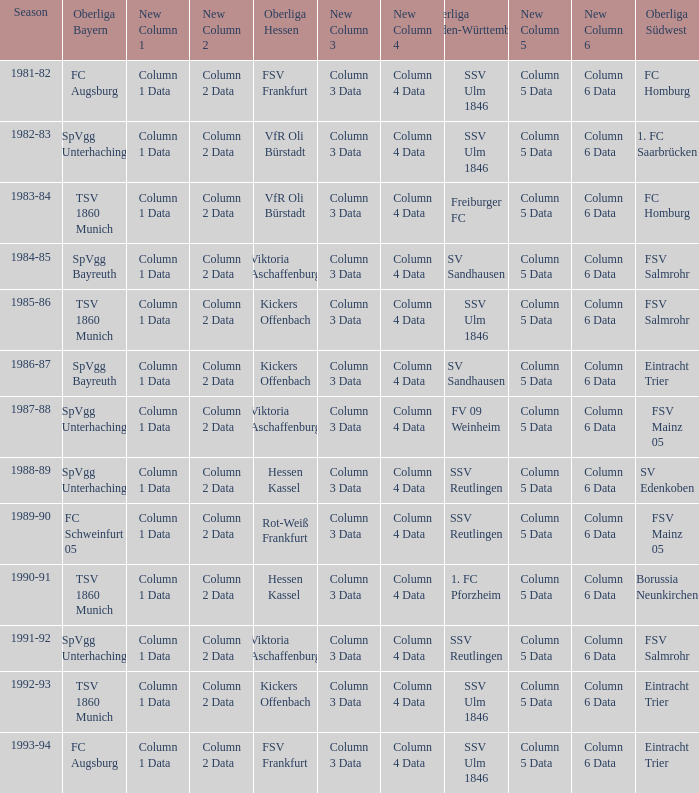Which Oberliga Südwest has an Oberliga Bayern of fc schweinfurt 05? FSV Mainz 05. 